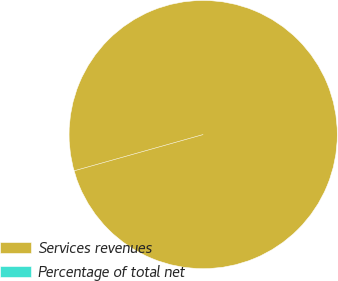Convert chart. <chart><loc_0><loc_0><loc_500><loc_500><pie_chart><fcel>Services revenues<fcel>Percentage of total net<nl><fcel>100.0%<fcel>0.0%<nl></chart> 